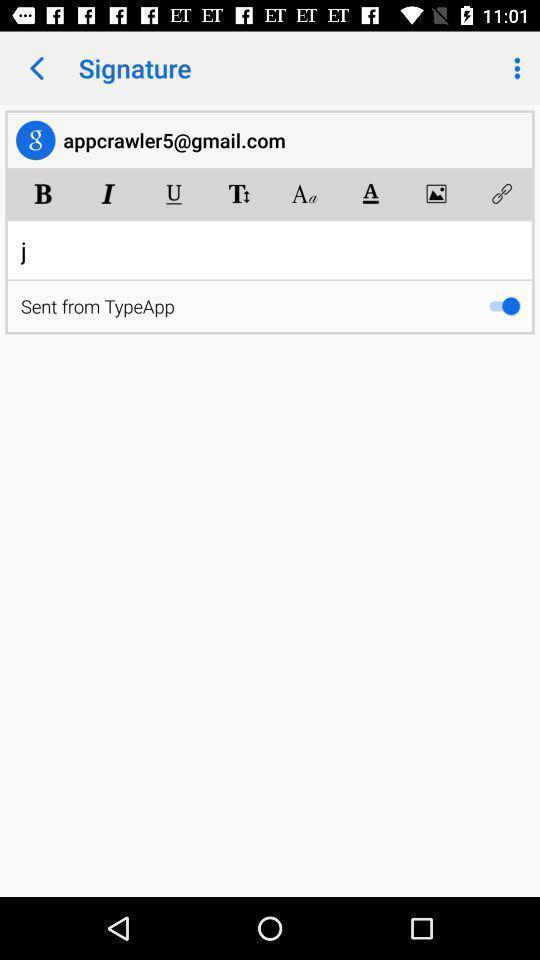Provide a textual representation of this image. Page displaying various options to design the text in application. 